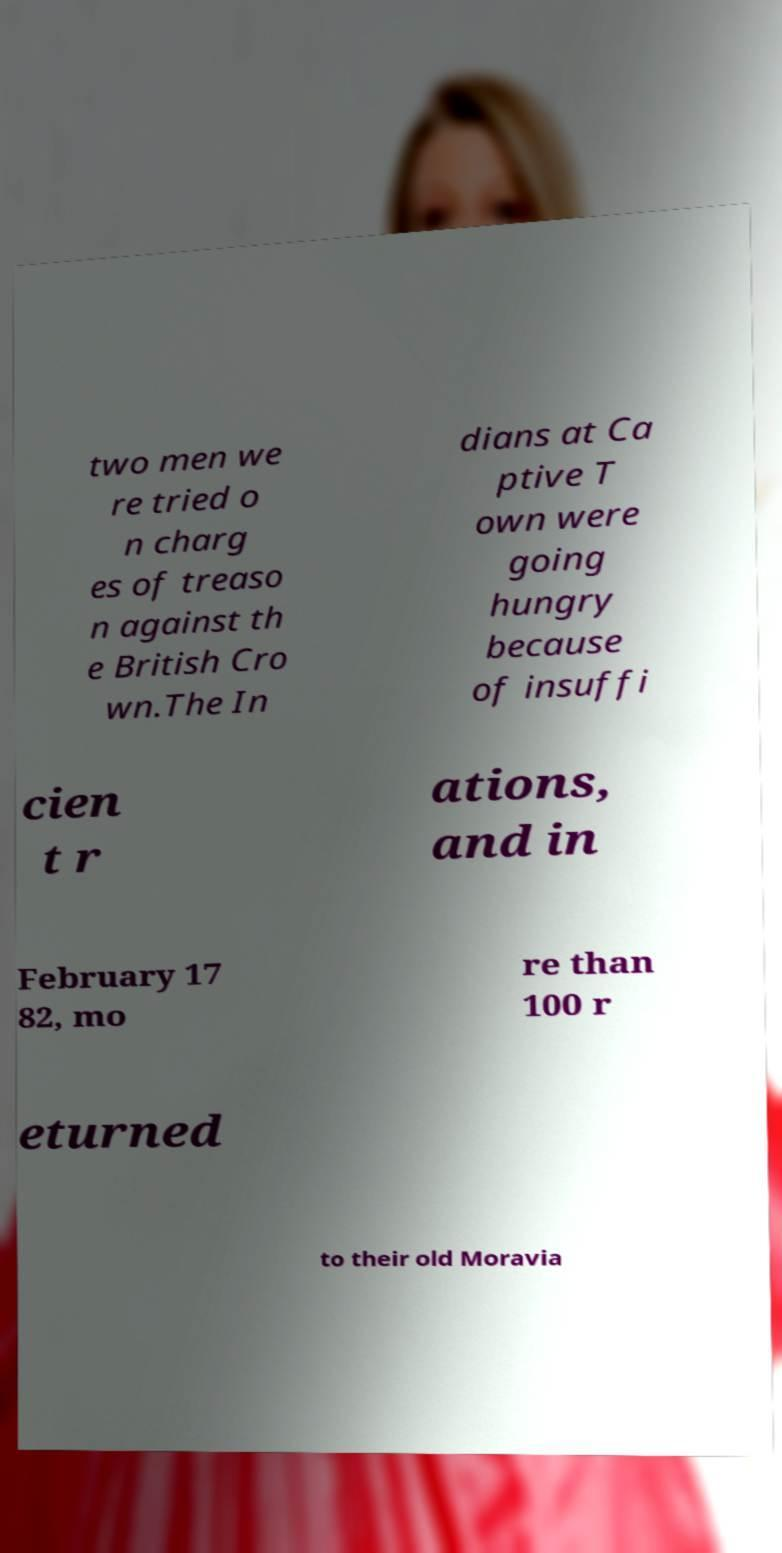Could you assist in decoding the text presented in this image and type it out clearly? two men we re tried o n charg es of treaso n against th e British Cro wn.The In dians at Ca ptive T own were going hungry because of insuffi cien t r ations, and in February 17 82, mo re than 100 r eturned to their old Moravia 